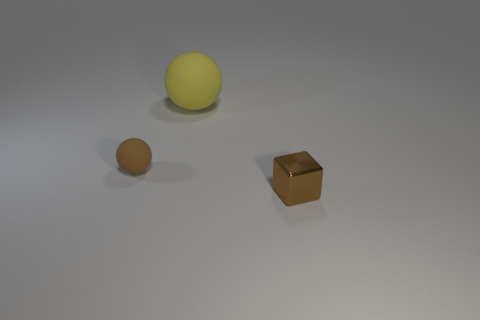Subtract all brown balls. How many balls are left? 1 Subtract 1 blocks. How many blocks are left? 0 Subtract 1 brown spheres. How many objects are left? 2 Subtract all cubes. How many objects are left? 2 Subtract all blue spheres. Subtract all yellow cylinders. How many spheres are left? 2 Subtract all purple balls. How many red cubes are left? 0 Subtract all red metallic balls. Subtract all small objects. How many objects are left? 1 Add 3 shiny things. How many shiny things are left? 4 Add 3 brown shiny objects. How many brown shiny objects exist? 4 Add 2 small brown spheres. How many objects exist? 5 